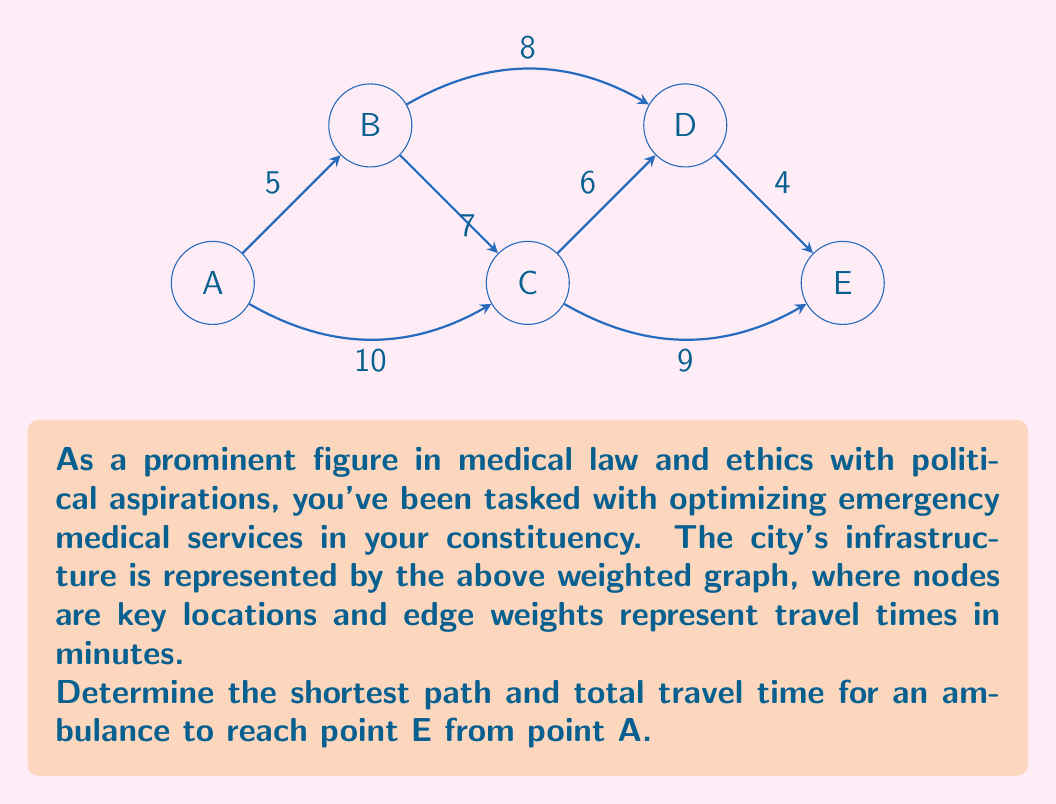What is the answer to this math problem? To solve this problem, we'll use Dijkstra's algorithm, which is ideal for finding the shortest path in a weighted graph. Let's proceed step-by-step:

1) Initialize:
   - Set distance to A as 0 and all other nodes as infinity.
   - Set all nodes as unvisited.
   - Set A as the current node.

2) For the current node, consider all unvisited neighbors and calculate their tentative distances:
   - A to B: 5 minutes
   - A to C: 10 minutes

3) Mark A as visited. B has the smallest tentative distance (5), so make B the current node.

4) From B:
   - B to C: 5 + 7 = 12 minutes (longer than direct A to C)
   - B to D: 5 + 8 = 13 minutes

5) Mark B as visited. C has the smallest tentative distance (10), so make C the current node.

6) From C:
   - C to D: 10 + 6 = 16 minutes (shorter than via B)
   - C to E: 10 + 9 = 19 minutes

7) Mark C as visited. D has the smallest tentative distance (16), so make D the current node.

8) From D:
   - D to E: 16 + 4 = 20 minutes (shorter than via C)

9) Mark D as visited. E is the only unvisited node left, so the algorithm ends.

The shortest path is A → C → D → E, with a total travel time of 20 minutes.
Answer: Path: A → C → D → E; Time: 20 minutes 